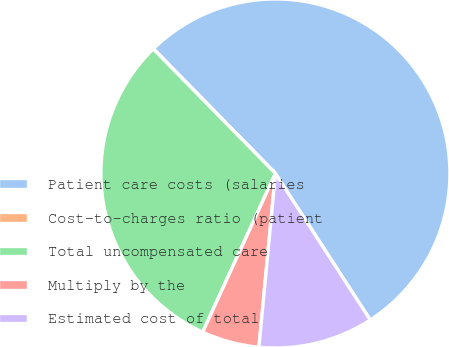Convert chart. <chart><loc_0><loc_0><loc_500><loc_500><pie_chart><fcel>Patient care costs (salaries<fcel>Cost-to-charges ratio (patient<fcel>Total uncompensated care<fcel>Multiply by the<fcel>Estimated cost of total<nl><fcel>53.18%<fcel>0.02%<fcel>30.81%<fcel>5.34%<fcel>10.65%<nl></chart> 